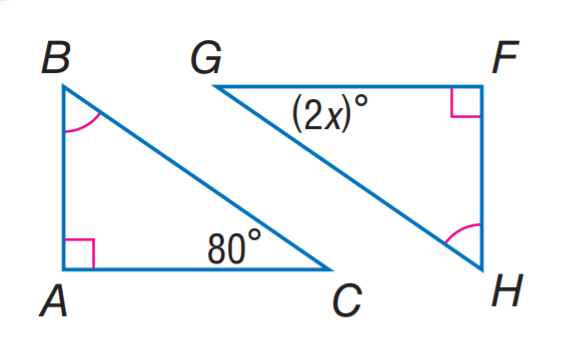Question: Find x.
Choices:
A. 30
B. 40
C. 50
D. 80
Answer with the letter. Answer: B 